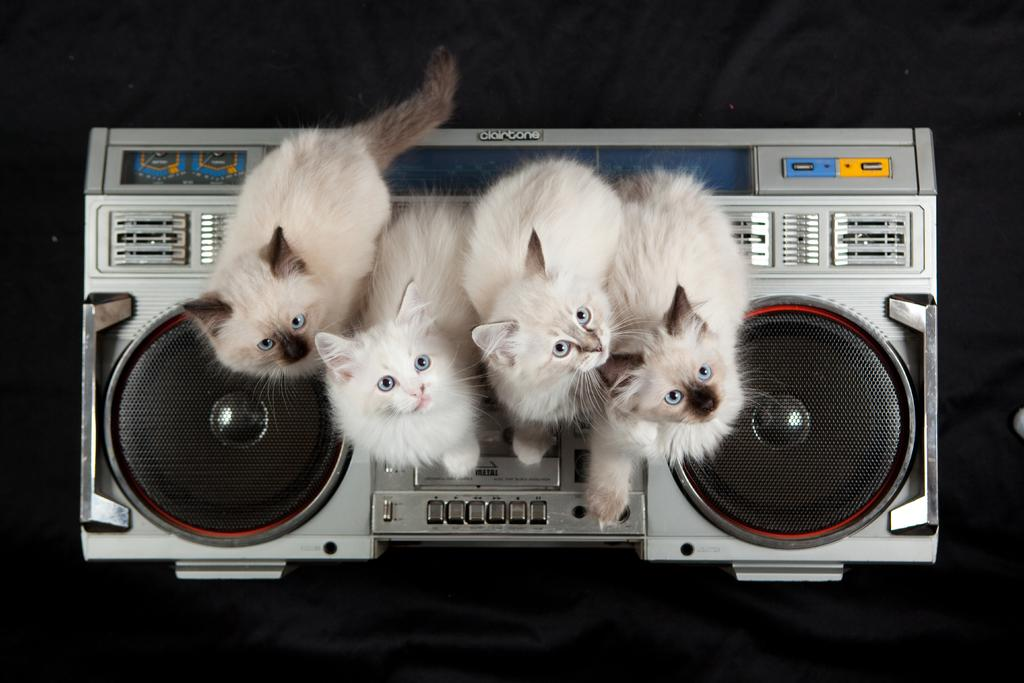What animals are present in the image? There are cats in the image. Where are the cats located? The cats are on an electronic gadget. What is the color of the background in the image? The background of the image is dark. How many strands of hair can be seen on the cats in the image? There is no mention of hair on the cats in the image, so it cannot be determined how many strands are visible. 